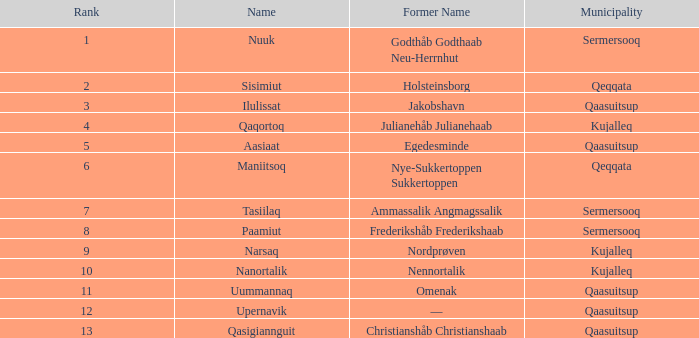What is the population for Rank 11? 1282.0. 